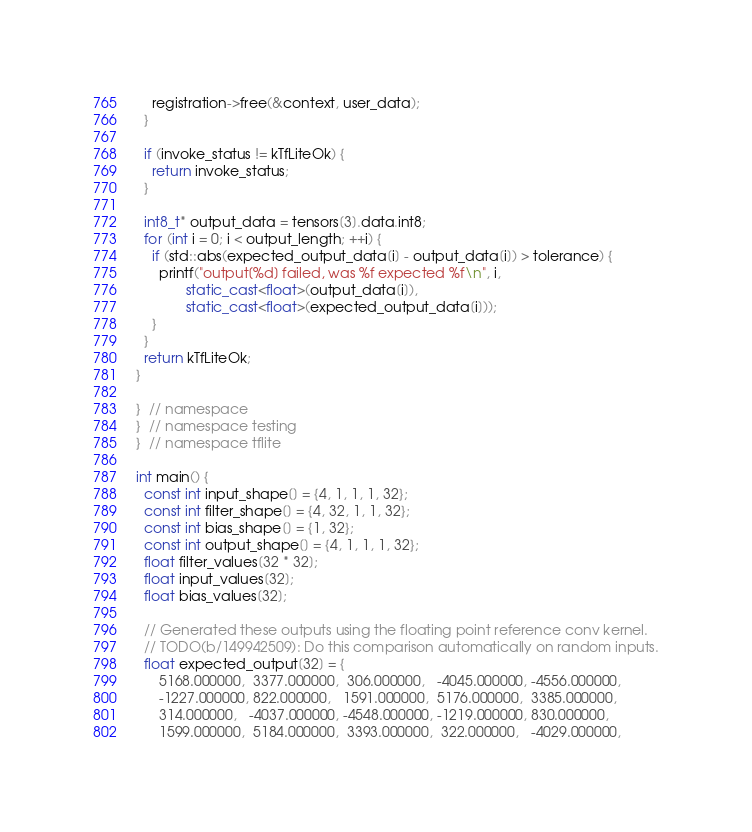Convert code to text. <code><loc_0><loc_0><loc_500><loc_500><_C++_>    registration->free(&context, user_data);
  }

  if (invoke_status != kTfLiteOk) {
    return invoke_status;
  }

  int8_t* output_data = tensors[3].data.int8;
  for (int i = 0; i < output_length; ++i) {
    if (std::abs(expected_output_data[i] - output_data[i]) > tolerance) {
      printf("output[%d] failed, was %f expected %f\n", i,
             static_cast<float>(output_data[i]),
             static_cast<float>(expected_output_data[i]));
    }
  }
  return kTfLiteOk;
}

}  // namespace
}  // namespace testing
}  // namespace tflite

int main() {
  const int input_shape[] = {4, 1, 1, 1, 32};
  const int filter_shape[] = {4, 32, 1, 1, 32};
  const int bias_shape[] = {1, 32};
  const int output_shape[] = {4, 1, 1, 1, 32};
  float filter_values[32 * 32];
  float input_values[32];
  float bias_values[32];

  // Generated these outputs using the floating point reference conv kernel.
  // TODO(b/149942509): Do this comparison automatically on random inputs.
  float expected_output[32] = {
      5168.000000,  3377.000000,  306.000000,   -4045.000000, -4556.000000,
      -1227.000000, 822.000000,   1591.000000,  5176.000000,  3385.000000,
      314.000000,   -4037.000000, -4548.000000, -1219.000000, 830.000000,
      1599.000000,  5184.000000,  3393.000000,  322.000000,   -4029.000000,</code> 